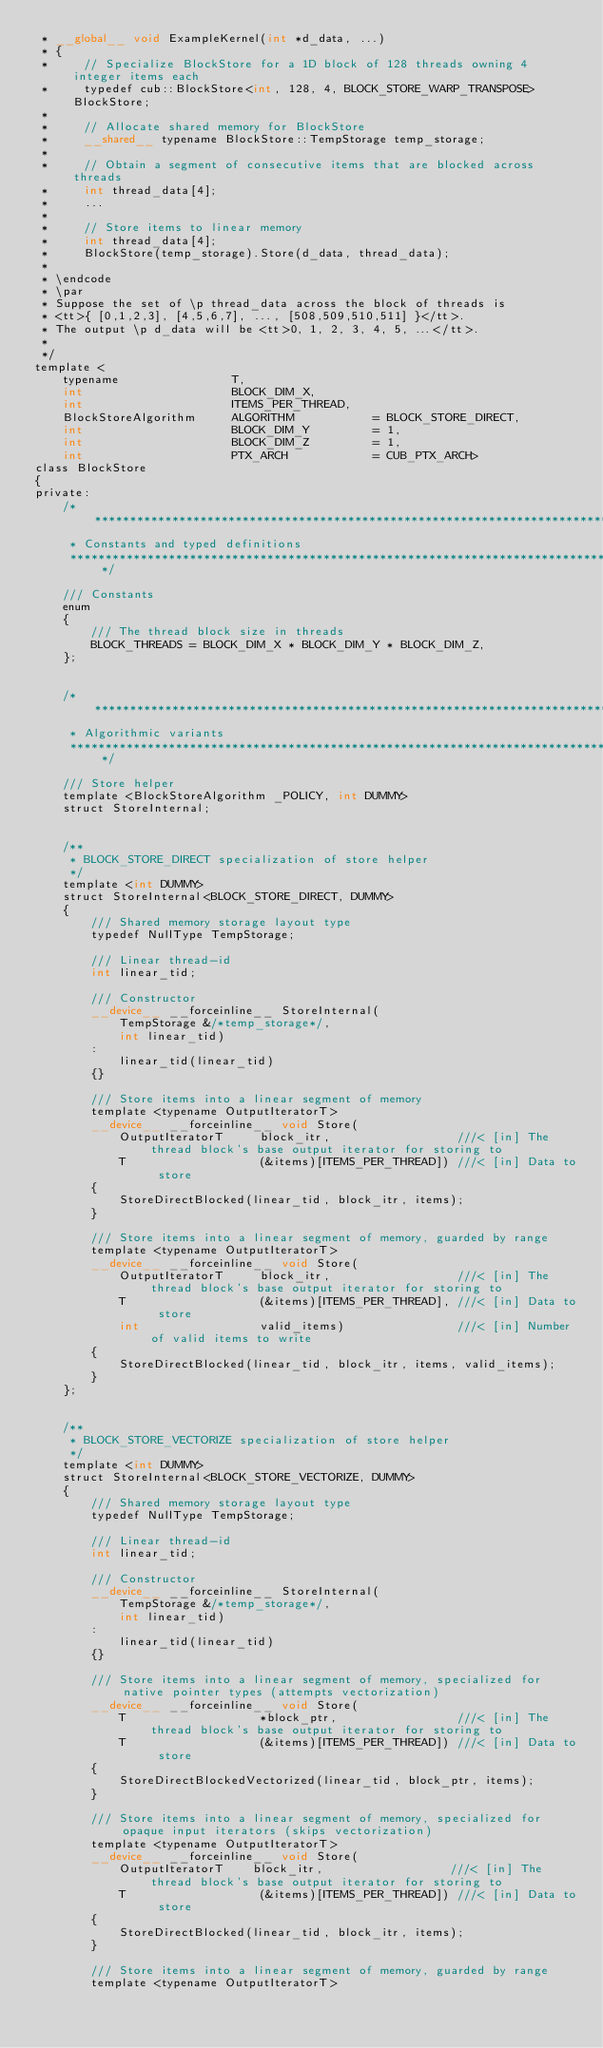Convert code to text. <code><loc_0><loc_0><loc_500><loc_500><_Cuda_> * __global__ void ExampleKernel(int *d_data, ...)
 * {
 *     // Specialize BlockStore for a 1D block of 128 threads owning 4 integer items each
 *     typedef cub::BlockStore<int, 128, 4, BLOCK_STORE_WARP_TRANSPOSE> BlockStore;
 *
 *     // Allocate shared memory for BlockStore
 *     __shared__ typename BlockStore::TempStorage temp_storage;
 *
 *     // Obtain a segment of consecutive items that are blocked across threads
 *     int thread_data[4];
 *     ...
 *
 *     // Store items to linear memory
 *     int thread_data[4];
 *     BlockStore(temp_storage).Store(d_data, thread_data);
 *
 * \endcode
 * \par
 * Suppose the set of \p thread_data across the block of threads is
 * <tt>{ [0,1,2,3], [4,5,6,7], ..., [508,509,510,511] }</tt>.
 * The output \p d_data will be <tt>0, 1, 2, 3, 4, 5, ...</tt>.
 *
 */
template <
    typename                T,
    int                     BLOCK_DIM_X,
    int                     ITEMS_PER_THREAD,
    BlockStoreAlgorithm     ALGORITHM           = BLOCK_STORE_DIRECT,
    int                     BLOCK_DIM_Y         = 1,
    int                     BLOCK_DIM_Z         = 1,
    int                     PTX_ARCH            = CUB_PTX_ARCH>
class BlockStore
{
private:
    /******************************************************************************
     * Constants and typed definitions
     ******************************************************************************/

    /// Constants
    enum
    {
        /// The thread block size in threads
        BLOCK_THREADS = BLOCK_DIM_X * BLOCK_DIM_Y * BLOCK_DIM_Z,
    };


    /******************************************************************************
     * Algorithmic variants
     ******************************************************************************/

    /// Store helper
    template <BlockStoreAlgorithm _POLICY, int DUMMY>
    struct StoreInternal;


    /**
     * BLOCK_STORE_DIRECT specialization of store helper
     */
    template <int DUMMY>
    struct StoreInternal<BLOCK_STORE_DIRECT, DUMMY>
    {
        /// Shared memory storage layout type
        typedef NullType TempStorage;

        /// Linear thread-id
        int linear_tid;

        /// Constructor
        __device__ __forceinline__ StoreInternal(
            TempStorage &/*temp_storage*/,
            int linear_tid)
        :
            linear_tid(linear_tid)
        {}

        /// Store items into a linear segment of memory
        template <typename OutputIteratorT>
        __device__ __forceinline__ void Store(
            OutputIteratorT     block_itr,                  ///< [in] The thread block's base output iterator for storing to
            T                   (&items)[ITEMS_PER_THREAD]) ///< [in] Data to store
        {
            StoreDirectBlocked(linear_tid, block_itr, items);
        }

        /// Store items into a linear segment of memory, guarded by range
        template <typename OutputIteratorT>
        __device__ __forceinline__ void Store(
            OutputIteratorT     block_itr,                  ///< [in] The thread block's base output iterator for storing to
            T                   (&items)[ITEMS_PER_THREAD], ///< [in] Data to store
            int                 valid_items)                ///< [in] Number of valid items to write
        {
            StoreDirectBlocked(linear_tid, block_itr, items, valid_items);
        }
    };


    /**
     * BLOCK_STORE_VECTORIZE specialization of store helper
     */
    template <int DUMMY>
    struct StoreInternal<BLOCK_STORE_VECTORIZE, DUMMY>
    {
        /// Shared memory storage layout type
        typedef NullType TempStorage;

        /// Linear thread-id
        int linear_tid;

        /// Constructor
        __device__ __forceinline__ StoreInternal(
            TempStorage &/*temp_storage*/,
            int linear_tid)
        :
            linear_tid(linear_tid)
        {}

        /// Store items into a linear segment of memory, specialized for native pointer types (attempts vectorization)
        __device__ __forceinline__ void Store(
            T                   *block_ptr,                 ///< [in] The thread block's base output iterator for storing to
            T                   (&items)[ITEMS_PER_THREAD]) ///< [in] Data to store
        {
            StoreDirectBlockedVectorized(linear_tid, block_ptr, items);
        }

        /// Store items into a linear segment of memory, specialized for opaque input iterators (skips vectorization)
        template <typename OutputIteratorT>
        __device__ __forceinline__ void Store(
            OutputIteratorT    block_itr,                  ///< [in] The thread block's base output iterator for storing to
            T                   (&items)[ITEMS_PER_THREAD]) ///< [in] Data to store
        {
            StoreDirectBlocked(linear_tid, block_itr, items);
        }

        /// Store items into a linear segment of memory, guarded by range
        template <typename OutputIteratorT></code> 